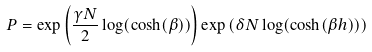Convert formula to latex. <formula><loc_0><loc_0><loc_500><loc_500>P = \exp \left ( \frac { \gamma N } { 2 } \log ( \cosh ( \beta ) ) \right ) \exp \left ( \delta N \log ( \cosh ( \beta h ) ) \right )</formula> 